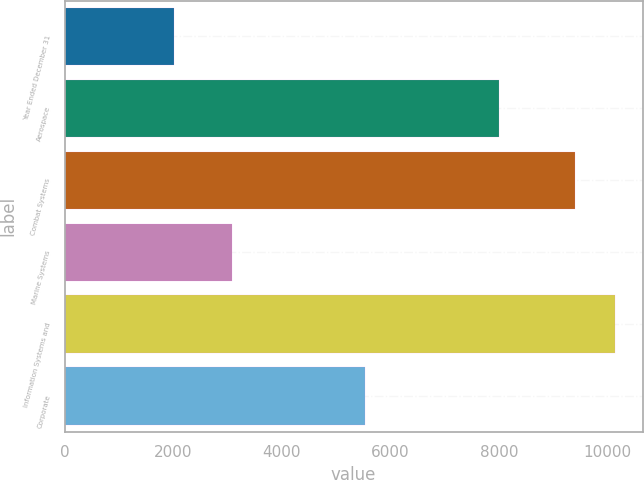<chart> <loc_0><loc_0><loc_500><loc_500><bar_chart><fcel>Year Ended December 31<fcel>Aerospace<fcel>Combat Systems<fcel>Marine Systems<fcel>Information Systems and<fcel>Corporate<nl><fcel>2013<fcel>8005<fcel>9393<fcel>3088<fcel>10134.9<fcel>5530<nl></chart> 